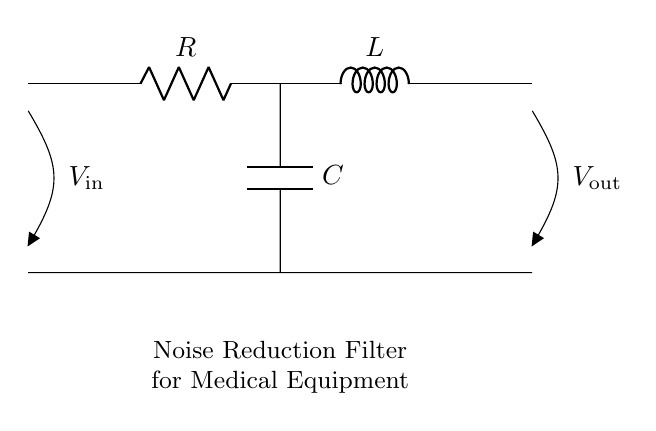What components are present in this circuit? The components are a resistor, an inductor, and a capacitor, which are common elements in RLC circuits used for filtering.
Answer: Resistor, Inductor, Capacitor What is the purpose of this circuit? The purpose is to reduce noise in medical equipment, which is indicated by the label on the circuit diagram. RLC circuits can filter out unwanted frequencies and signal noise.
Answer: Noise Reduction Filter What type of filter is represented in this diagram? This circuit represents a passive filter, as it consists of passive components (resistor, inductor, capacitor) that do not amplify the signal but instead attenuate unwanted frequencies.
Answer: Passive Filter What happens to the voltage between the input and output? The voltage experiences a reduction in certain frequency components. The circuit configuration allows it to filter out noise, thus output voltage may be less than the input voltage, dependent on the frequency of the input signal.
Answer: Attenuation What is the role of the inductor in this circuit? The inductor opposes changes in current and can store energy in a magnetic field. In an RLC filter, it helps to block high frequencies while allowing lower frequencies to pass through, contributing to the noise reduction function.
Answer: Blocks high frequencies What is the relationship between resistance, inductance, and capacitance in this filter? The relationship defines the filter's frequency response. The resonant frequency is determined by the values of R, L, and C, and the combination affects the cutoff frequency where noise is attenuated. For precise filtering, appropriate values must be chosen based on the desired application.
Answer: Defines frequency response 